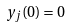Convert formula to latex. <formula><loc_0><loc_0><loc_500><loc_500>y _ { j } ( 0 ) = 0</formula> 